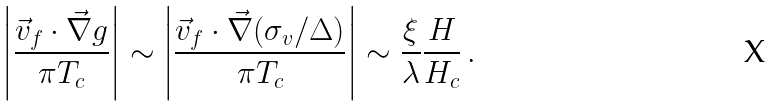<formula> <loc_0><loc_0><loc_500><loc_500>\left | \frac { \vec { v } _ { f } \cdot \vec { \nabla } g } { \pi T _ { c } } \right | \sim \left | \frac { \vec { v } _ { f } \cdot \vec { \nabla } ( \sigma _ { v } / \Delta ) } { \pi T _ { c } } \right | \sim \frac { \xi } { \lambda } \frac { H } { H _ { c } } \, .</formula> 